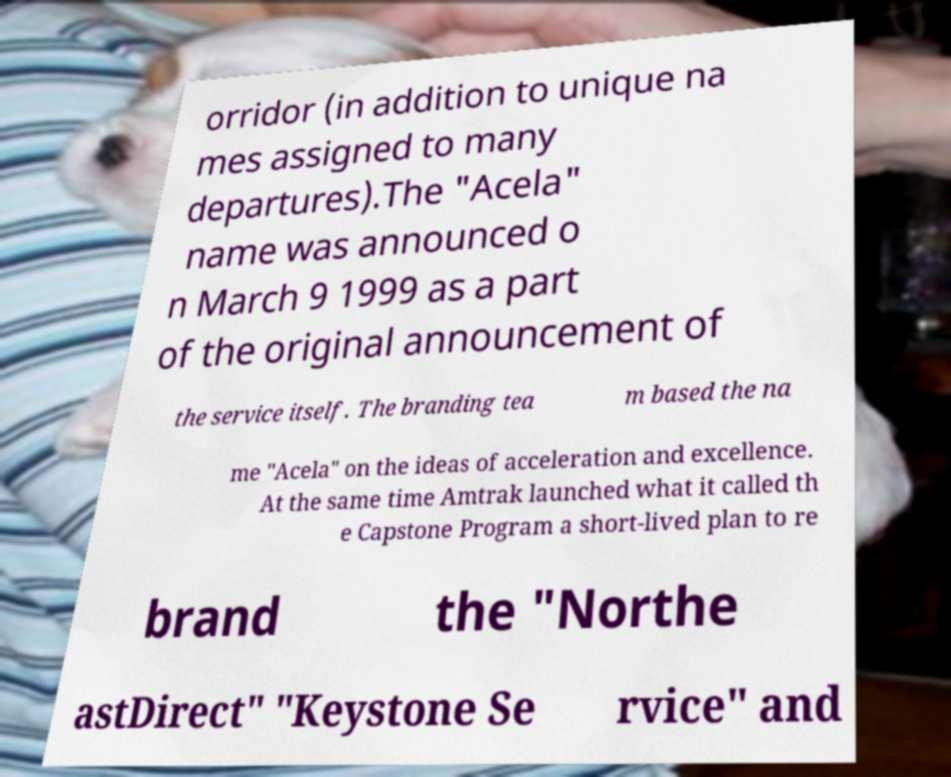Can you read and provide the text displayed in the image?This photo seems to have some interesting text. Can you extract and type it out for me? orridor (in addition to unique na mes assigned to many departures).The "Acela" name was announced o n March 9 1999 as a part of the original announcement of the service itself. The branding tea m based the na me "Acela" on the ideas of acceleration and excellence. At the same time Amtrak launched what it called th e Capstone Program a short-lived plan to re brand the "Northe astDirect" "Keystone Se rvice" and 